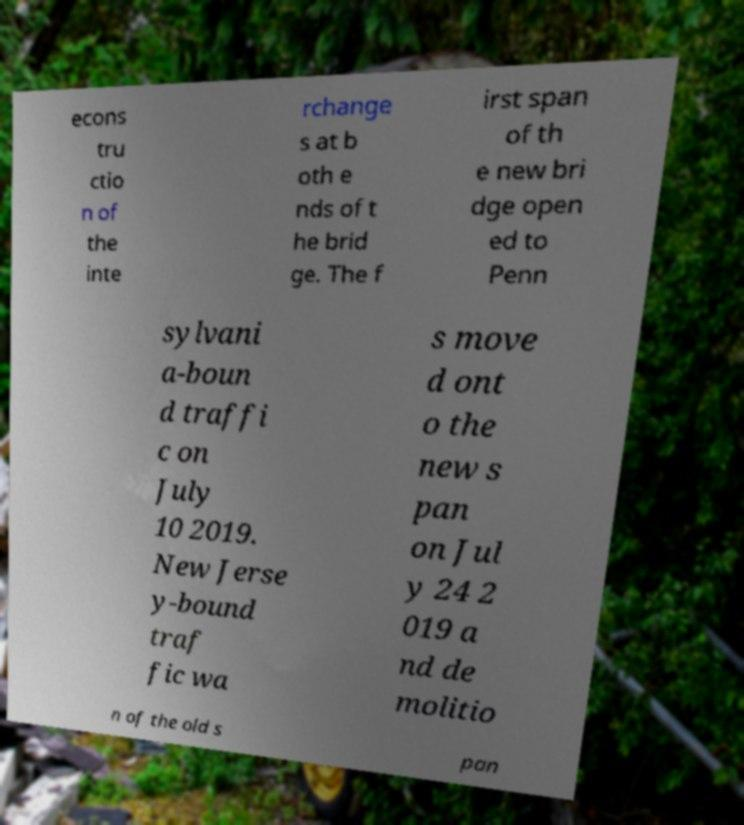Could you extract and type out the text from this image? econs tru ctio n of the inte rchange s at b oth e nds of t he brid ge. The f irst span of th e new bri dge open ed to Penn sylvani a-boun d traffi c on July 10 2019. New Jerse y-bound traf fic wa s move d ont o the new s pan on Jul y 24 2 019 a nd de molitio n of the old s pan 